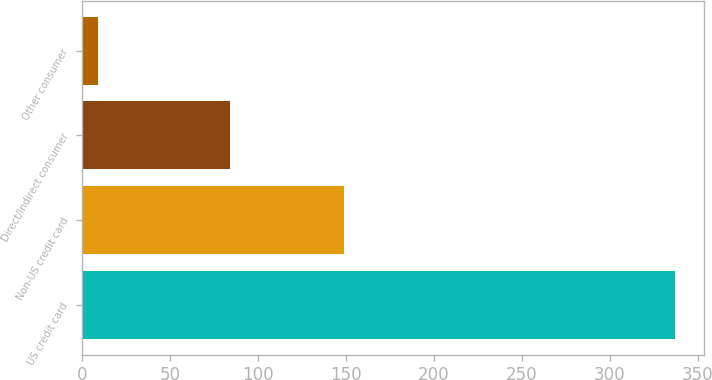Convert chart. <chart><loc_0><loc_0><loc_500><loc_500><bar_chart><fcel>US credit card<fcel>Non-US credit card<fcel>Direct/Indirect consumer<fcel>Other consumer<nl><fcel>337<fcel>149<fcel>84<fcel>9<nl></chart> 